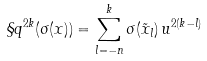Convert formula to latex. <formula><loc_0><loc_0><loc_500><loc_500>\S q ^ { 2 k } ( \sigma ( x ) ) = \sum _ { l = - n } ^ { k } \sigma ( \tilde { x } _ { l } ) \, u ^ { 2 ( k - l ) }</formula> 